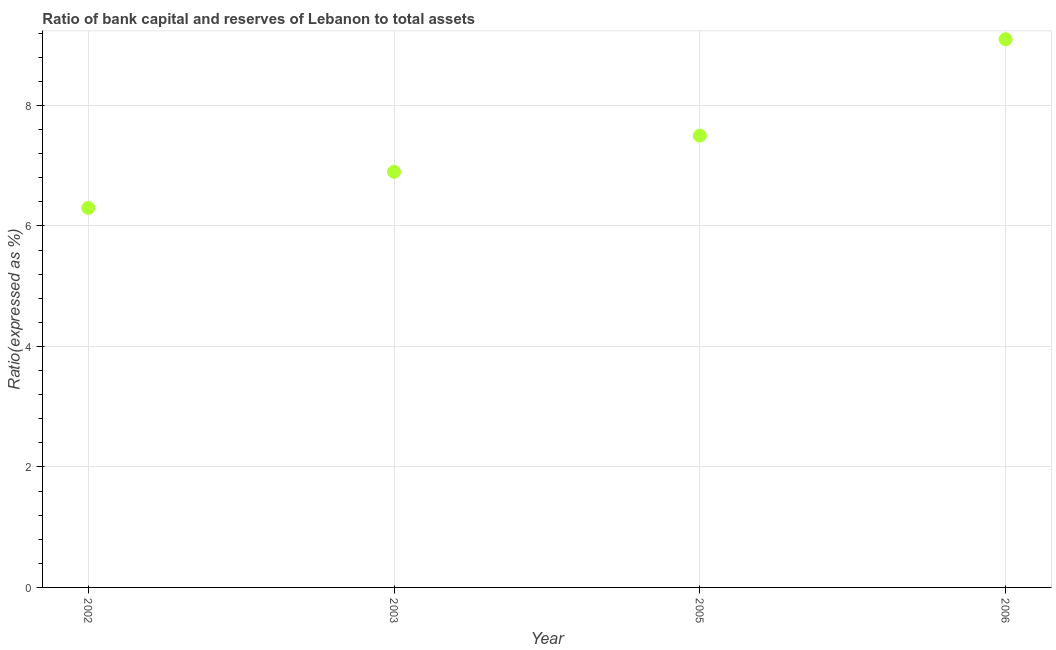Across all years, what is the minimum bank capital to assets ratio?
Give a very brief answer. 6.3. In which year was the bank capital to assets ratio maximum?
Keep it short and to the point. 2006. What is the sum of the bank capital to assets ratio?
Make the answer very short. 29.8. What is the difference between the bank capital to assets ratio in 2002 and 2006?
Your answer should be compact. -2.8. What is the average bank capital to assets ratio per year?
Offer a terse response. 7.45. What is the median bank capital to assets ratio?
Your answer should be very brief. 7.2. In how many years, is the bank capital to assets ratio greater than 2 %?
Your answer should be compact. 4. Do a majority of the years between 2006 and 2003 (inclusive) have bank capital to assets ratio greater than 4.8 %?
Give a very brief answer. No. What is the ratio of the bank capital to assets ratio in 2003 to that in 2006?
Offer a very short reply. 0.76. Is the difference between the bank capital to assets ratio in 2003 and 2006 greater than the difference between any two years?
Your response must be concise. No. What is the difference between the highest and the second highest bank capital to assets ratio?
Ensure brevity in your answer.  1.6. In how many years, is the bank capital to assets ratio greater than the average bank capital to assets ratio taken over all years?
Your answer should be compact. 2. How many years are there in the graph?
Provide a short and direct response. 4. Does the graph contain any zero values?
Keep it short and to the point. No. Does the graph contain grids?
Provide a short and direct response. Yes. What is the title of the graph?
Give a very brief answer. Ratio of bank capital and reserves of Lebanon to total assets. What is the label or title of the Y-axis?
Your answer should be very brief. Ratio(expressed as %). What is the Ratio(expressed as %) in 2002?
Make the answer very short. 6.3. What is the Ratio(expressed as %) in 2006?
Keep it short and to the point. 9.1. What is the difference between the Ratio(expressed as %) in 2002 and 2006?
Your answer should be compact. -2.8. What is the difference between the Ratio(expressed as %) in 2003 and 2005?
Give a very brief answer. -0.6. What is the difference between the Ratio(expressed as %) in 2003 and 2006?
Offer a terse response. -2.2. What is the difference between the Ratio(expressed as %) in 2005 and 2006?
Provide a succinct answer. -1.6. What is the ratio of the Ratio(expressed as %) in 2002 to that in 2003?
Ensure brevity in your answer.  0.91. What is the ratio of the Ratio(expressed as %) in 2002 to that in 2005?
Your response must be concise. 0.84. What is the ratio of the Ratio(expressed as %) in 2002 to that in 2006?
Ensure brevity in your answer.  0.69. What is the ratio of the Ratio(expressed as %) in 2003 to that in 2006?
Offer a very short reply. 0.76. What is the ratio of the Ratio(expressed as %) in 2005 to that in 2006?
Your response must be concise. 0.82. 